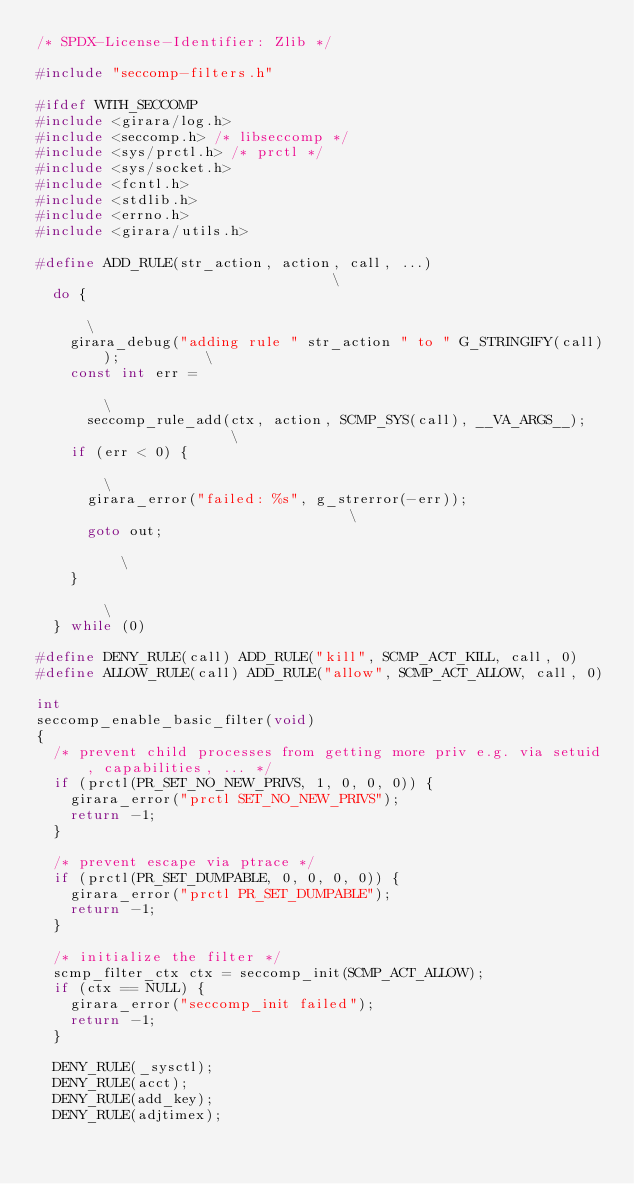<code> <loc_0><loc_0><loc_500><loc_500><_C_>/* SPDX-License-Identifier: Zlib */

#include "seccomp-filters.h"

#ifdef WITH_SECCOMP
#include <girara/log.h>
#include <seccomp.h> /* libseccomp */
#include <sys/prctl.h> /* prctl */
#include <sys/socket.h>
#include <fcntl.h>
#include <stdlib.h>
#include <errno.h>
#include <girara/utils.h>

#define ADD_RULE(str_action, action, call, ...)                                \
  do {                                                                         \
    girara_debug("adding rule " str_action " to " G_STRINGIFY(call));          \
    const int err =                                                            \
      seccomp_rule_add(ctx, action, SCMP_SYS(call), __VA_ARGS__);              \
    if (err < 0) {                                                             \
      girara_error("failed: %s", g_strerror(-err));                            \
      goto out;                                                                \
    }                                                                          \
  } while (0)

#define DENY_RULE(call) ADD_RULE("kill", SCMP_ACT_KILL, call, 0)
#define ALLOW_RULE(call) ADD_RULE("allow", SCMP_ACT_ALLOW, call, 0)

int
seccomp_enable_basic_filter(void)
{
  /* prevent child processes from getting more priv e.g. via setuid, capabilities, ... */
  if (prctl(PR_SET_NO_NEW_PRIVS, 1, 0, 0, 0)) {
    girara_error("prctl SET_NO_NEW_PRIVS");
    return -1;
  }

  /* prevent escape via ptrace */
  if (prctl(PR_SET_DUMPABLE, 0, 0, 0, 0)) {
    girara_error("prctl PR_SET_DUMPABLE");
    return -1;
  }

  /* initialize the filter */
  scmp_filter_ctx ctx = seccomp_init(SCMP_ACT_ALLOW);
  if (ctx == NULL) {
    girara_error("seccomp_init failed");
    return -1;
  }

  DENY_RULE(_sysctl);
  DENY_RULE(acct);
  DENY_RULE(add_key);
  DENY_RULE(adjtimex);</code> 